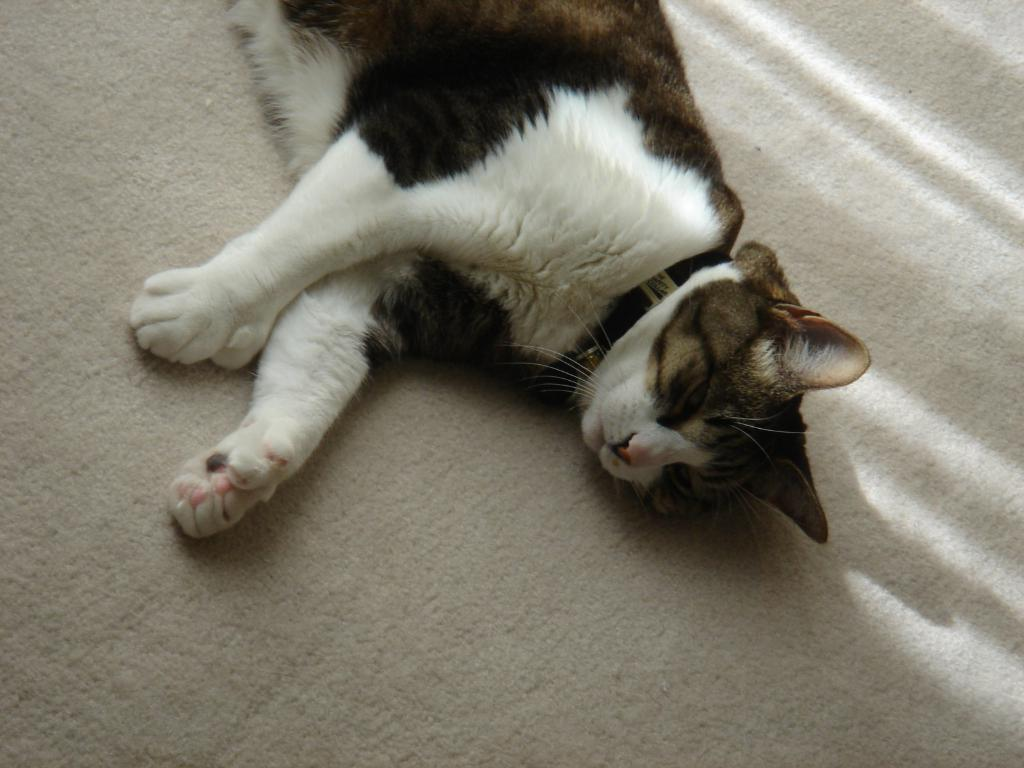What type of animal is in the image? There is a cat in the image. What colors can be seen on the cat? The cat has black, white, and brown colors. What is the cat sitting on in the image? The cat is on a white surface. How does the cat walk on the white surface in the image? The cat is not walking in the image; it is sitting on the white surface. 